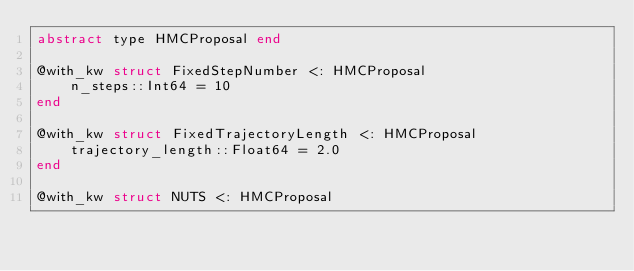Convert code to text. <code><loc_0><loc_0><loc_500><loc_500><_Julia_>abstract type HMCProposal end

@with_kw struct FixedStepNumber <: HMCProposal
    n_steps::Int64 = 10
end

@with_kw struct FixedTrajectoryLength <: HMCProposal
    trajectory_length::Float64 = 2.0
end

@with_kw struct NUTS <: HMCProposal</code> 